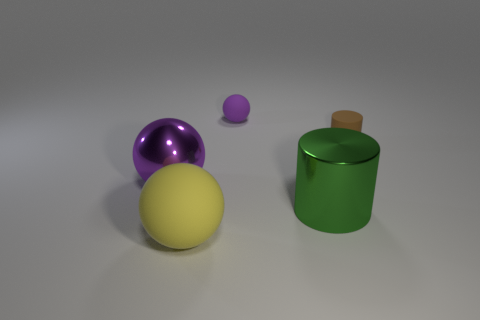Subtract all large rubber balls. How many balls are left? 2 Subtract all brown cubes. How many purple spheres are left? 2 Add 5 balls. How many objects exist? 10 Subtract all yellow balls. How many balls are left? 2 Subtract all cylinders. How many objects are left? 3 Add 3 big metallic things. How many big metallic things are left? 5 Add 2 small purple shiny blocks. How many small purple shiny blocks exist? 2 Subtract 0 gray cubes. How many objects are left? 5 Subtract all gray balls. Subtract all blue blocks. How many balls are left? 3 Subtract all purple balls. Subtract all big yellow matte things. How many objects are left? 2 